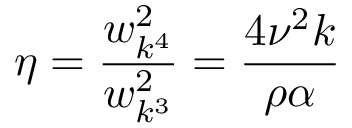Convert formula to latex. <formula><loc_0><loc_0><loc_500><loc_500>\eta = \frac { w _ { k ^ { 4 } } ^ { 2 } } { w _ { k ^ { 3 } } ^ { 2 } } = \frac { 4 \nu ^ { 2 } k } { \rho \alpha }</formula> 